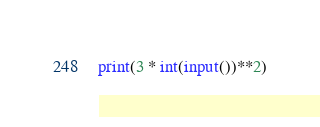<code> <loc_0><loc_0><loc_500><loc_500><_Python_>print(3 * int(input())**2)</code> 